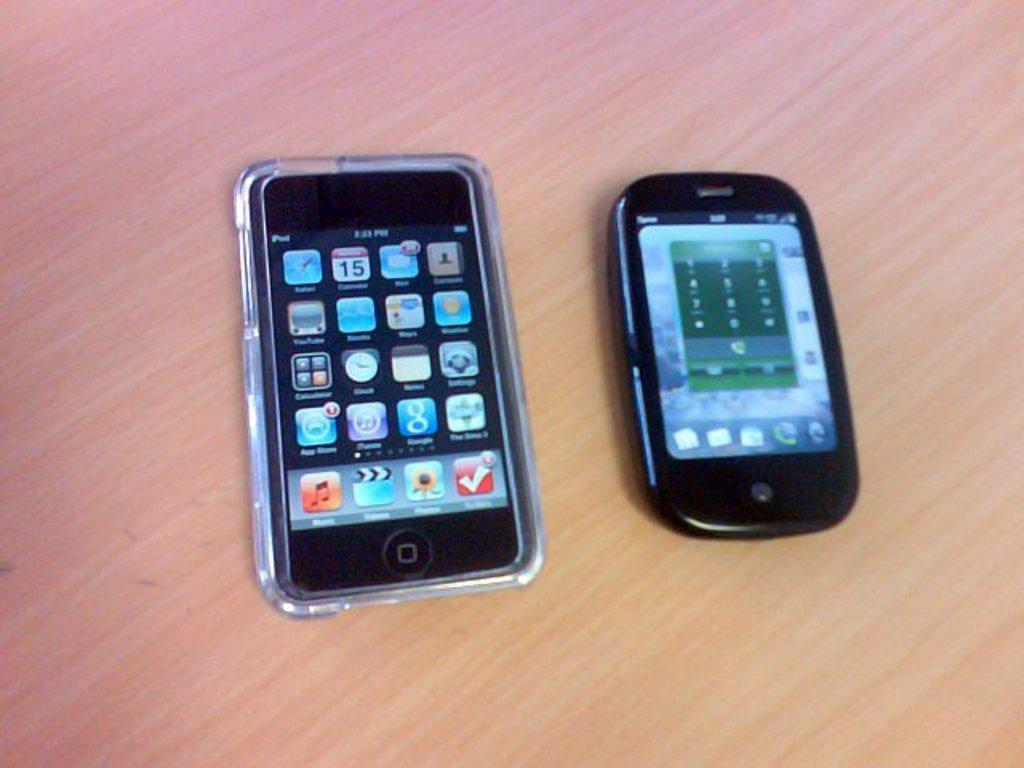<image>
Give a short and clear explanation of the subsequent image. a cell phone and an iPod showing icons on a table 